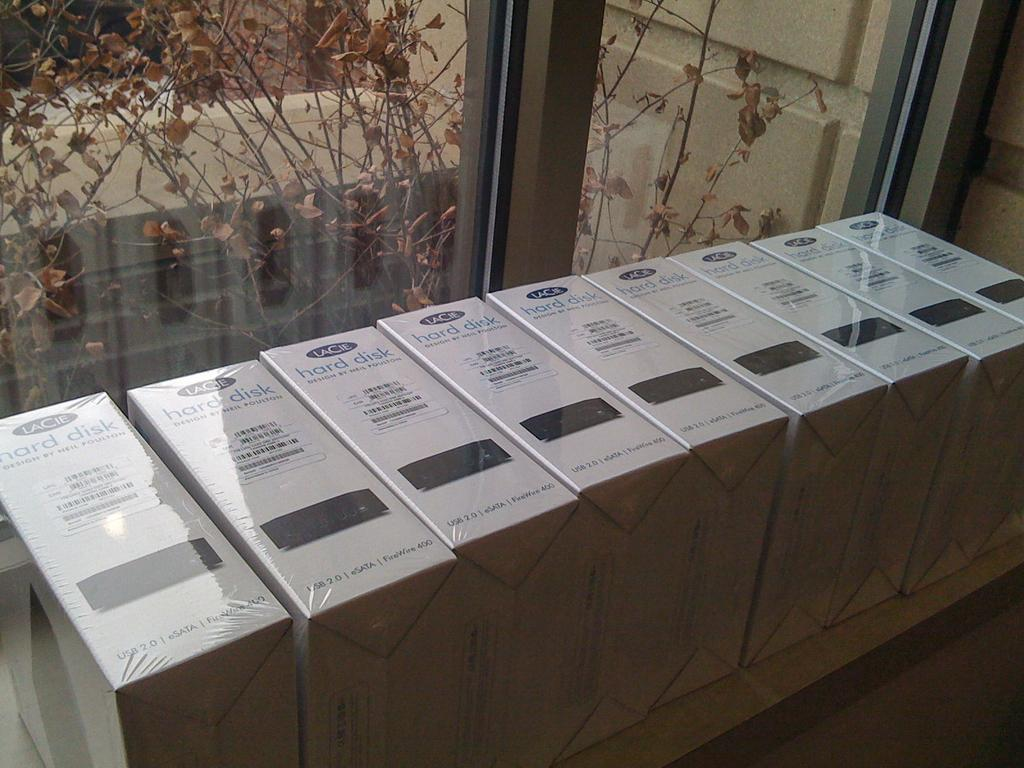What is located in the center of the image? There are boxes in the center of the image. What can be seen in the background of the image? There is a window in the background of the image. What is visible through the window? A tree with leaves is visible through the window. How many feet are visible in the image? There are no feet visible in the image. What type of balls can be seen in the image? There are no balls present in the image. 